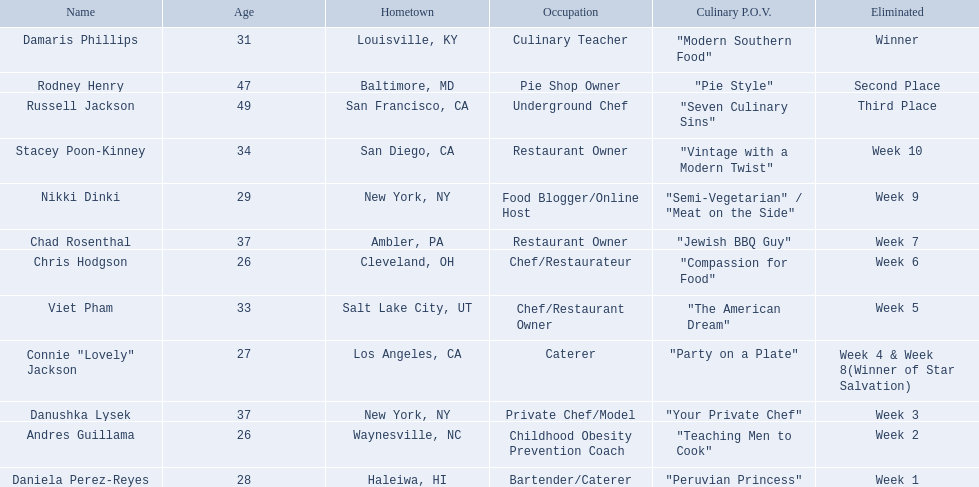Who are all those included in the list? Damaris Phillips, Rodney Henry, Russell Jackson, Stacey Poon-Kinney, Nikki Dinki, Chad Rosenthal, Chris Hodgson, Viet Pham, Connie "Lovely" Jackson, Danushka Lysek, Andres Guillama, Daniela Perez-Reyes. What are their ages? 31, 47, 49, 34, 29, 37, 26, 33, 27, 37, 26, 28. Apart from chris hodgson, who is another person aged 26? Andres Guillama. Omitting the victor, and the ones who achieved second and third spots, who were the competitors who were removed? Stacey Poon-Kinney, Nikki Dinki, Chad Rosenthal, Chris Hodgson, Viet Pham, Connie "Lovely" Jackson, Danushka Lysek, Andres Guillama, Daniela Perez-Reyes. Of these competitors, who were the last five dismissed before the top three winners were declared? Stacey Poon-Kinney, Nikki Dinki, Chad Rosenthal, Chris Hodgson, Viet Pham. Of these five contestants, did nikki dinki or viet pham leave the competition first? Viet Pham. 